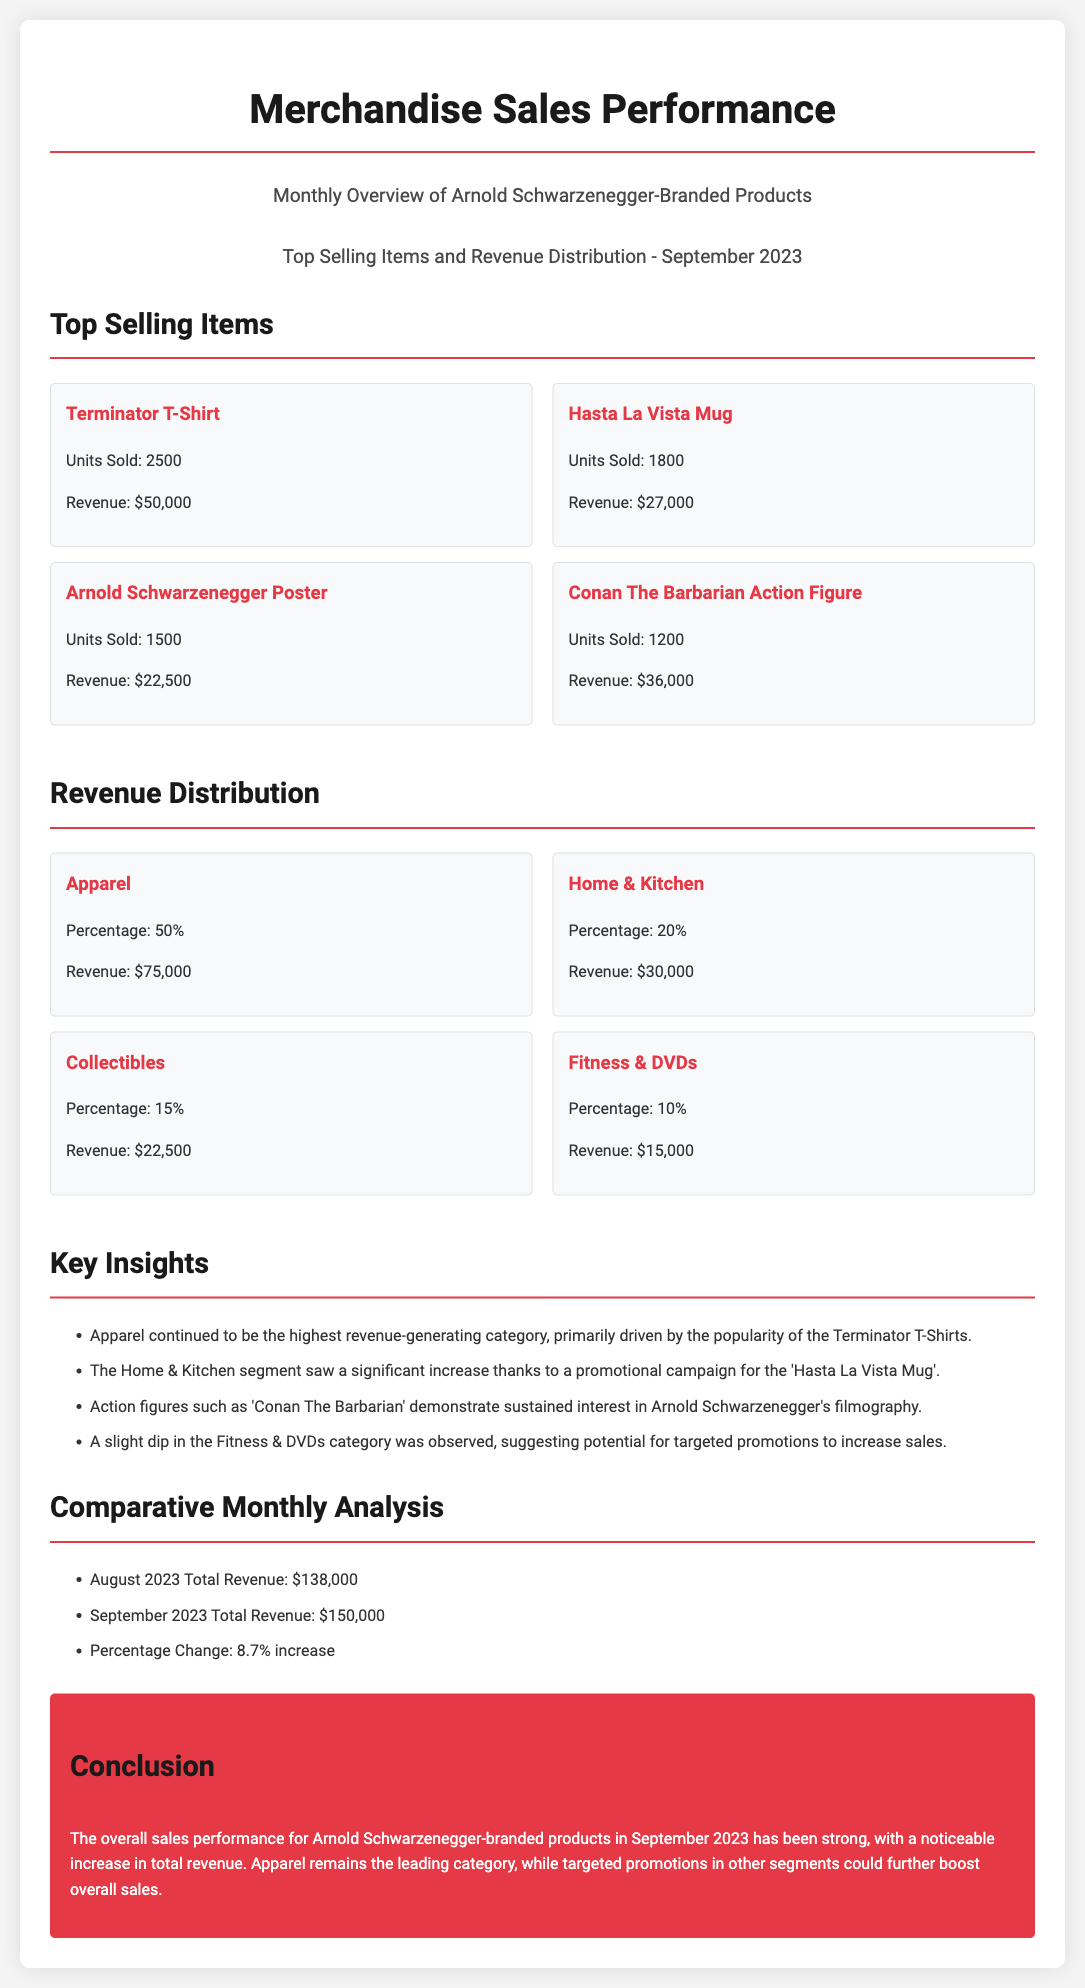What are the top-selling items? The document lists the top-selling items including the Terminator T-Shirt, Hasta La Vista Mug, Arnold Schwarzenegger Poster, and Conan The Barbarian Action Figure.
Answer: Terminator T-Shirt, Hasta La Vista Mug, Arnold Schwarzenegger Poster, Conan The Barbarian Action Figure How much revenue did the Terminator T-Shirt generate? The document states that the revenue for the Terminator T-Shirt is $50,000.
Answer: $50,000 What percentage of revenue does the Apparel category contribute? The document indicates that Apparel contributes 50% of the total revenue.
Answer: 50% How many units of Hasta La Vista Mug were sold? The document specifies that 1800 units of the Hasta La Vista Mug were sold.
Answer: 1800 What was the total revenue for September 2023? The document mentions that the total revenue for September 2023 is $150,000.
Answer: $150,000 Which category saw an increase due to a promotional campaign? The document highlights that the Home & Kitchen segment saw a significant increase due to a promotional campaign for the Hasta La Vista Mug.
Answer: Home & Kitchen What is the percentage change in total revenue from August to September 2023? The document states that there was an 8.7% increase in total revenue from August to September 2023.
Answer: 8.7% 